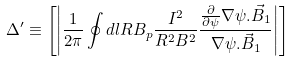<formula> <loc_0><loc_0><loc_500><loc_500>\Delta ^ { \prime } \equiv \left [ \left | \frac { 1 } { 2 \pi } \oint d l R B _ { p } \frac { I ^ { 2 } } { R ^ { 2 } B ^ { 2 } } \frac { \frac { \partial } { \partial \psi } \nabla \psi . \vec { B } _ { 1 } } { \nabla \psi . \vec { B } _ { 1 } } \right | \right ]</formula> 